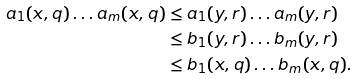<formula> <loc_0><loc_0><loc_500><loc_500>a _ { 1 } ( x , q ) \dots a _ { m } ( x , q ) & \leq a _ { 1 } ( y , r ) \dots a _ { m } ( y , r ) \\ & \leq b _ { 1 } ( y , r ) \dots b _ { m } ( y , r ) \\ & \leq b _ { 1 } ( x , q ) \dots b _ { m } ( x , q ) .</formula> 